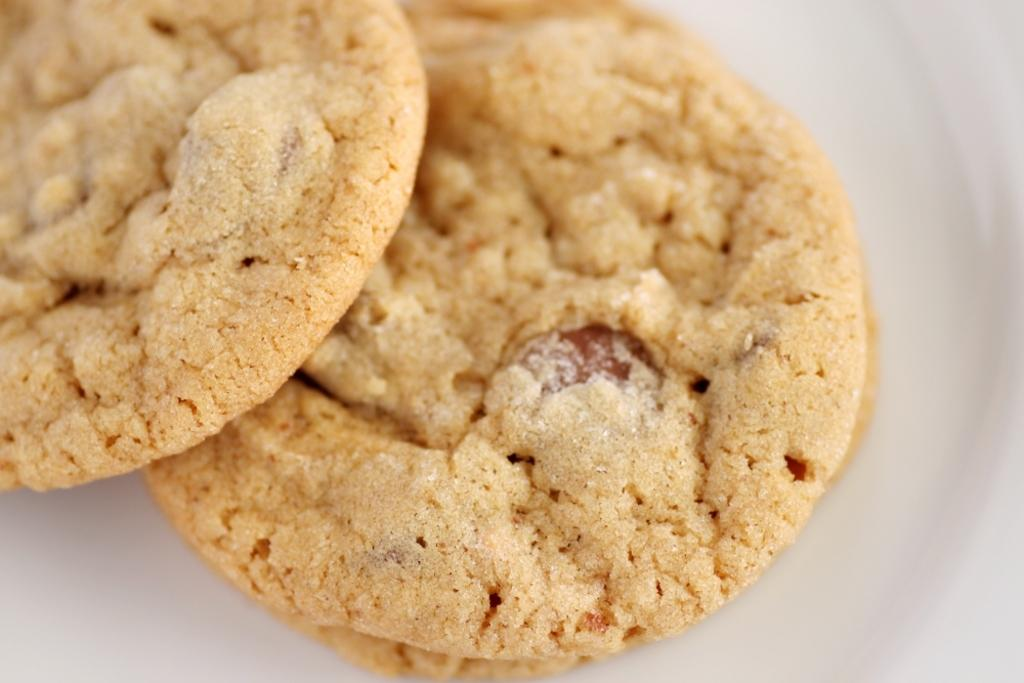What type of food is visible on the plate in the image? There are three cookies on a plate in the image. Can you describe the arrangement of the cookies on the plate? The cookies are arranged in a row on the plate. What might someone do with the cookies on the plate? Someone might eat the cookies or use them for decoration. What type of loss is depicted in the image? There is no loss depicted in the image; it simply shows three cookies on a plate. 